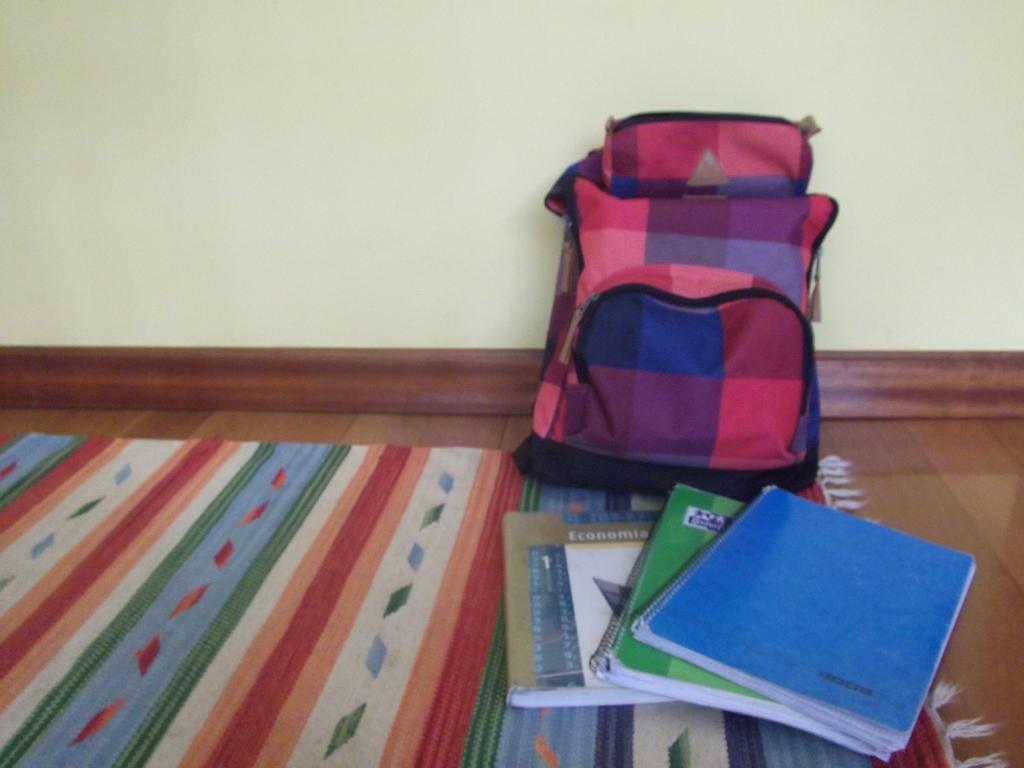What object can be seen in the image that might be used for carrying items? There is a bag in the image that might be used for carrying items. What items are on the floor in the image? There are books on the floor in the image. What is the books resting on in the image? The books are on a mat in the image. What type of neck accessory is visible in the image? There is no neck accessory present in the image. Can you describe the alley where the books are located in the image? There is no alley present in the image; it is an indoor setting with a bag, books, and a mat. 